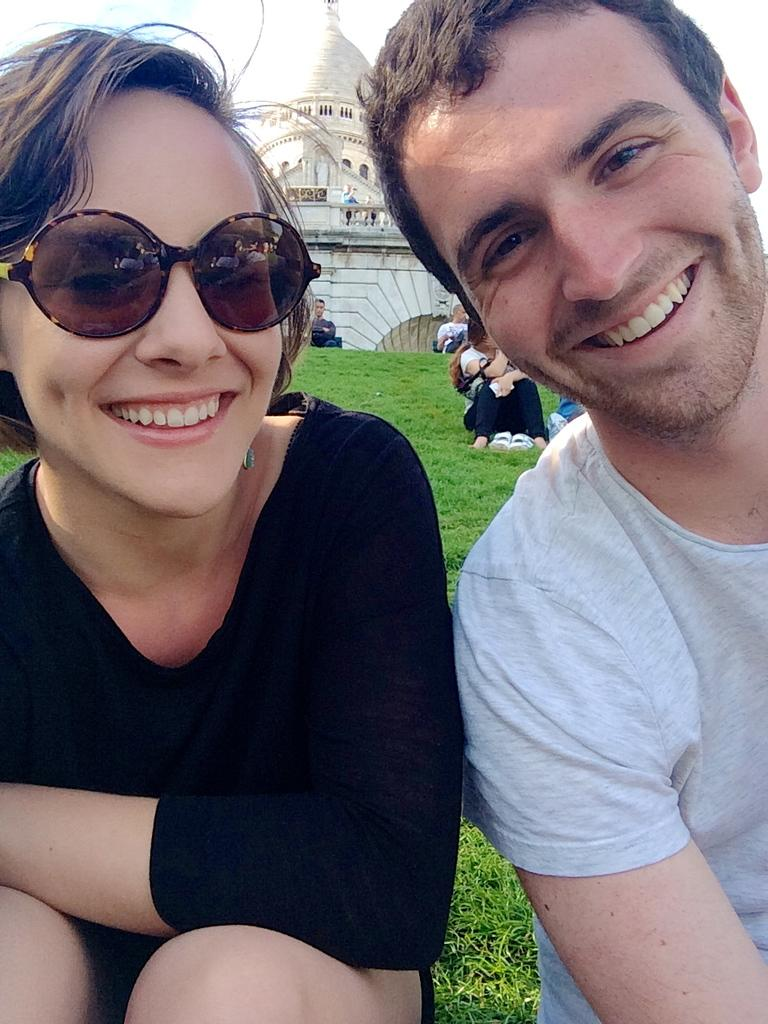Who is present in the image? There is a woman and a man in the image. What are the facial expressions of the people in the image? Both the woman and the man are smiling in the image. What is the woman wearing on her face? The woman is wearing goggles in the image. What can be seen in the background of the image? There is a building and people in the background of the image. What type of friction is present between the woman and the man in the image? There is no indication of friction between the woman and the man in the image; they are both smiling. Can you tell me how much paste the man is holding in the image? There is no paste present in the image. 